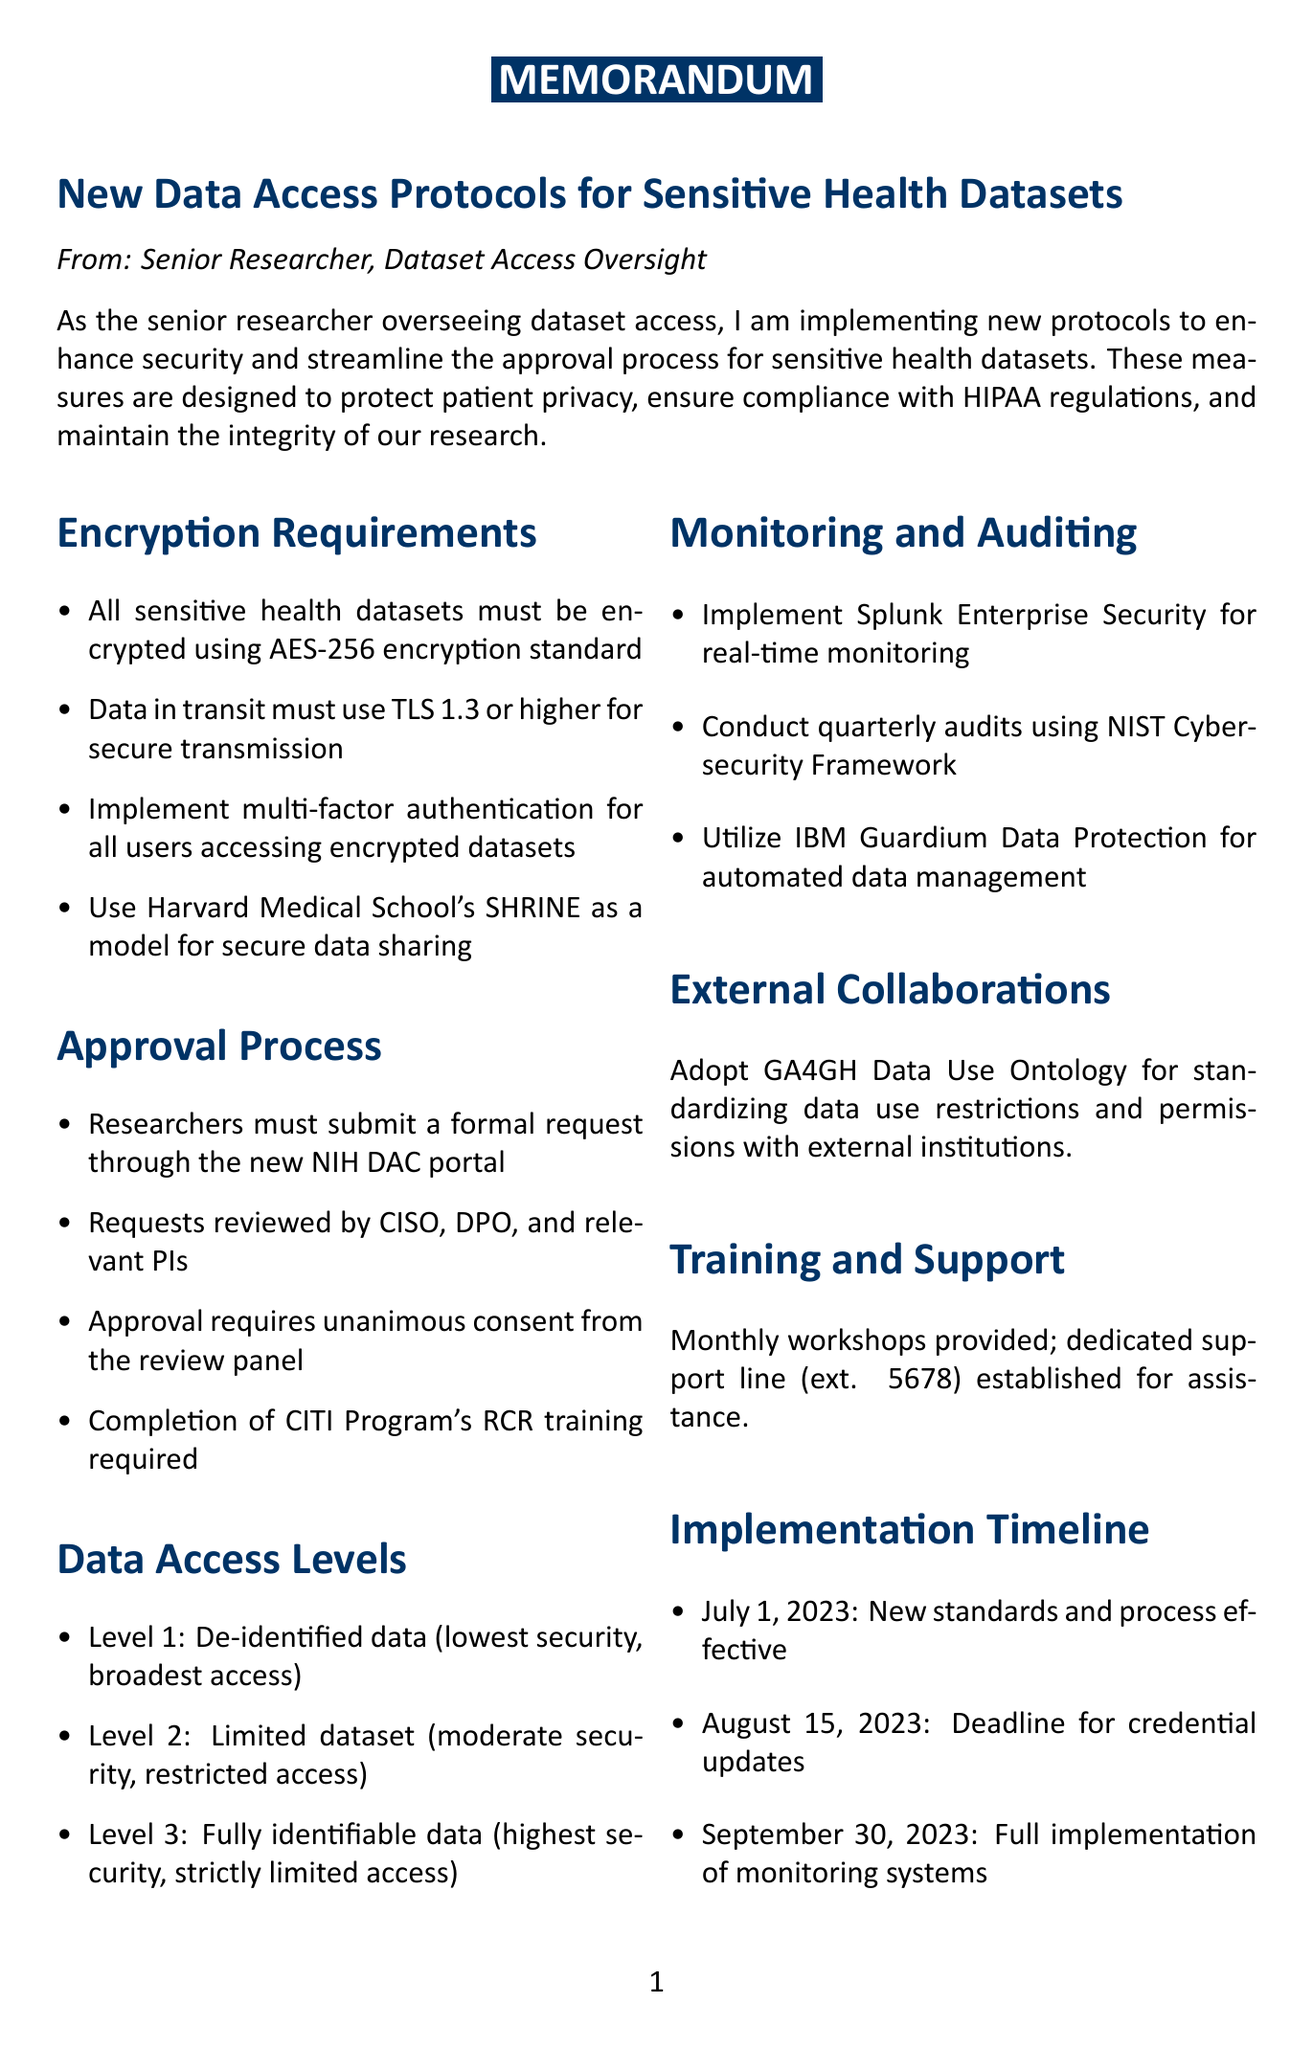What is the encryption standard required for sensitive health datasets? The document specifies that all sensitive health datasets must be encrypted using the AES-256 encryption standard.
Answer: AES-256 Who must review the requests submitted through the NIH DAC portal? The requests will be reviewed by a panel including the Chief Information Security Officer, Data Protection Officer, and relevant Principal Investigators.
Answer: CISO, DPO, and relevant PIs What is the implementation deadline for all researchers to update their data access credentials? The document states that the completion deadline for all researchers to update their data access credentials is August 15, 2023.
Answer: August 15, 2023 What level of data access is described as having the highest security? The document mentions that fully identifiable data is the level that has the highest security and strictly limited access.
Answer: Fully identifiable data When will the new encryption standards and approval process go into effect? According to the implementation timeline, the new encryption standards and approval process will go into effect on July 1, 2023.
Answer: July 1, 2023 What type of training must researchers complete before access is granted? The document specifies that researchers must complete the updated CITI Program's Responsible Conduct of Research training before access is granted.
Answer: CITI Program's RCR training What tools will be used for real-time monitoring of data access? The document states that Splunk Enterprise Security will be implemented for real-time monitoring of data access.
Answer: Splunk Enterprise Security What is the purpose of the GA4GH Data Use Ontology mentioned in the memo? The GA4GH Data Use Ontology is adopted to standardize data use restrictions and permissions for collaborations involving sensitive health data sharing with external institutions.
Answer: Standardize data use restrictions and permissions 